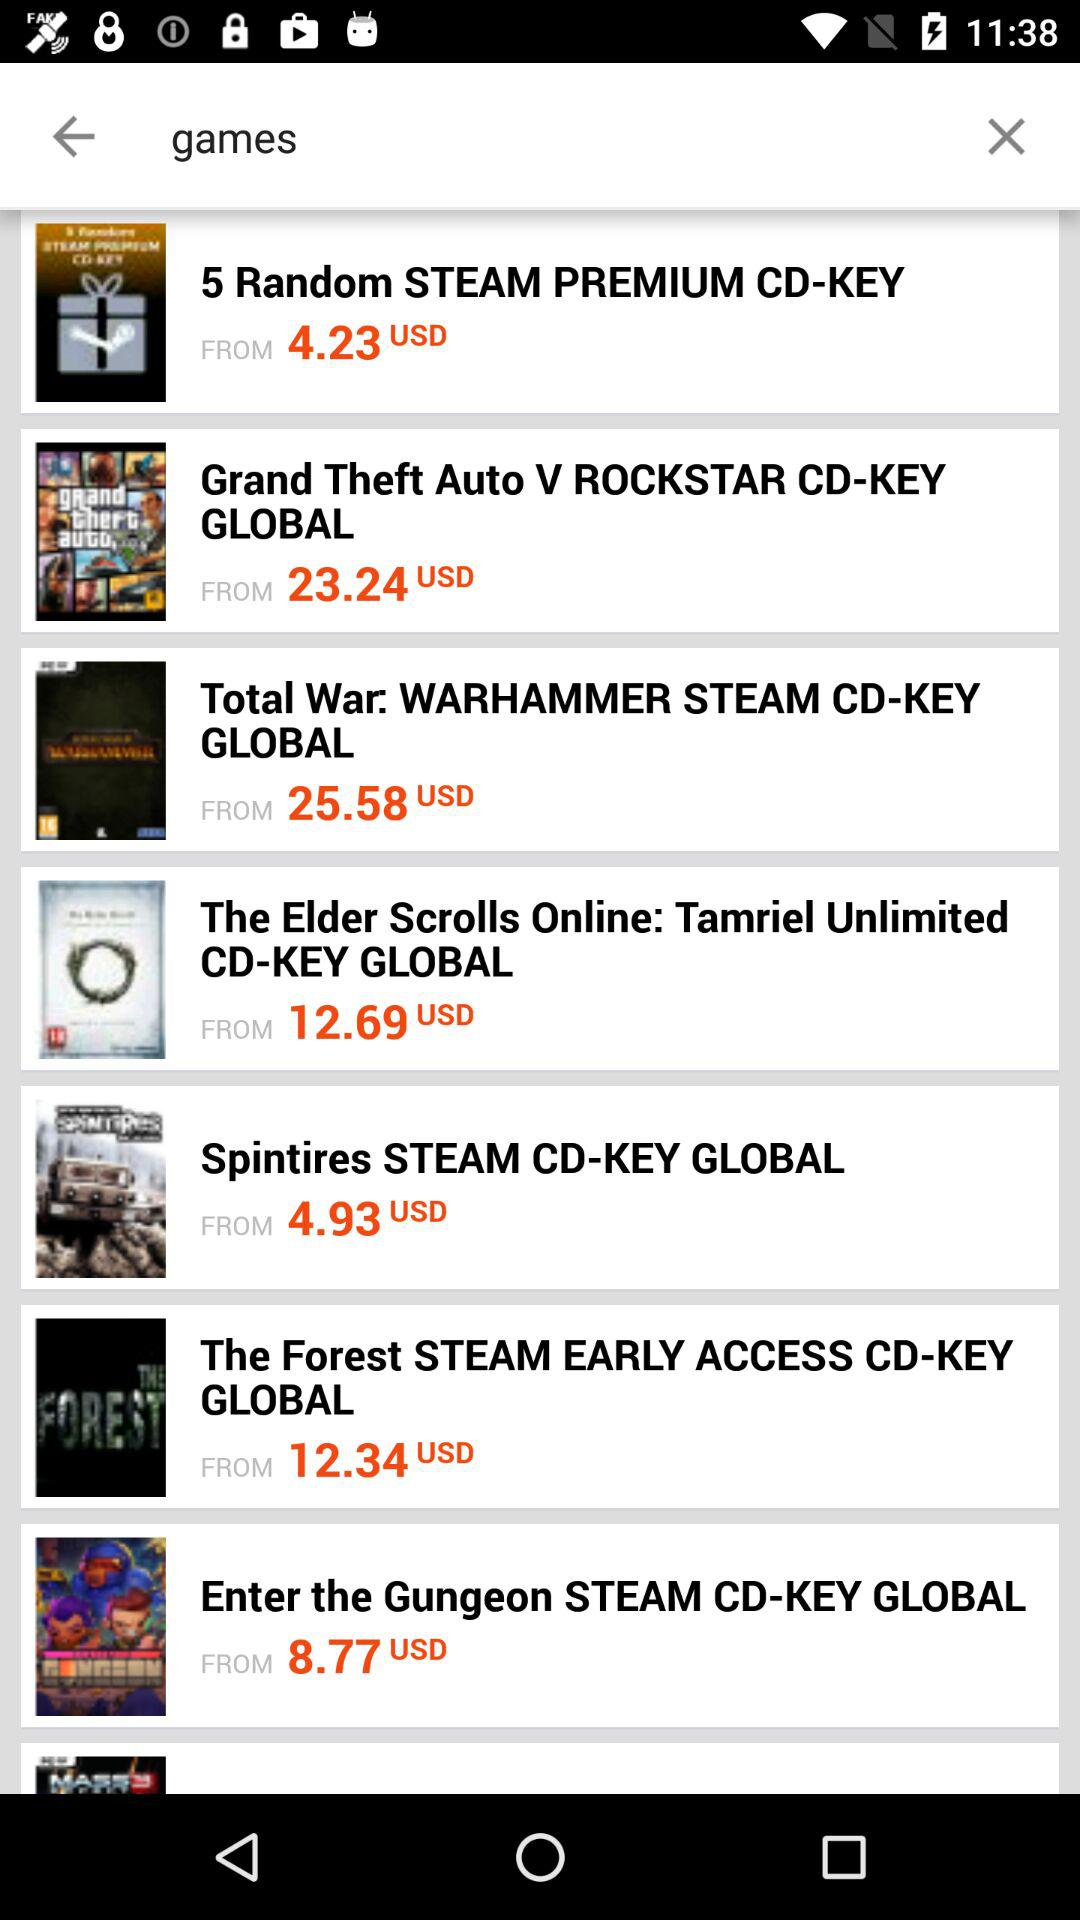Which game costs 12.34 USD? The game "The Forest" costs 12.34 USD. 